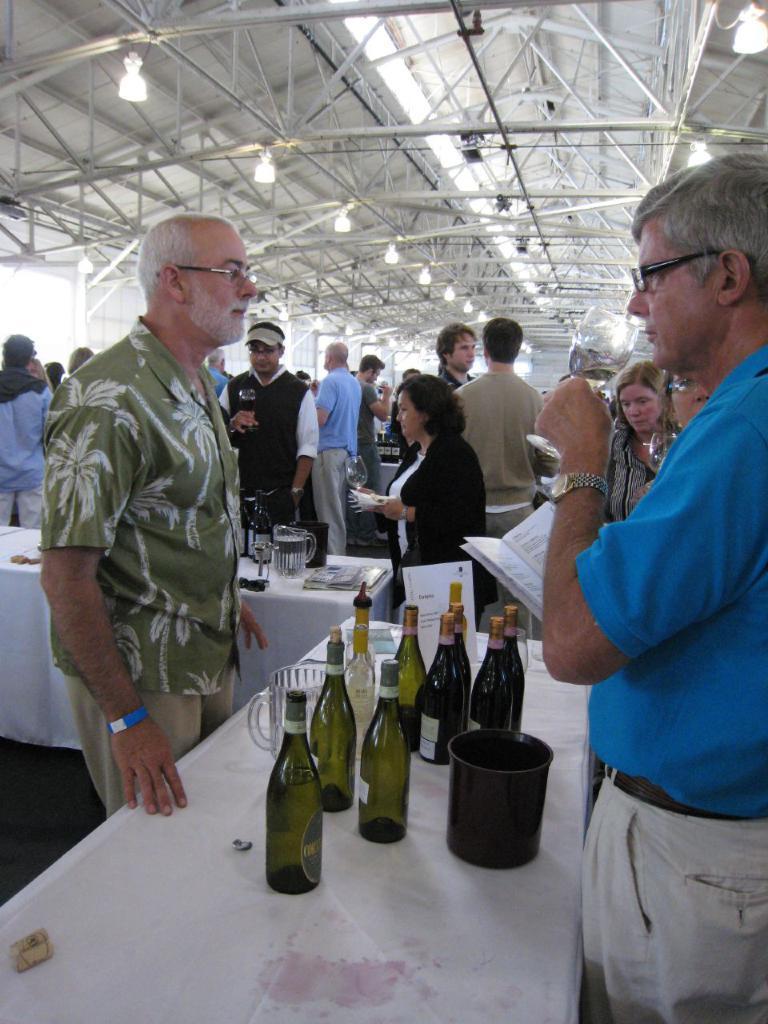Describe this image in one or two sentences. There are group of people in this image standing and walking. The person wearing a green colour shirt in the center is standing. In front of this person there is a table. On the table there are group of bottles, jar and a black colour container. At the right side the person wearing a blue colour shirt is holding a book in his hand. In the background there are persons standing. On the top there are lights hanging on the roof. The table in the center is covered with the white colour cloth. 